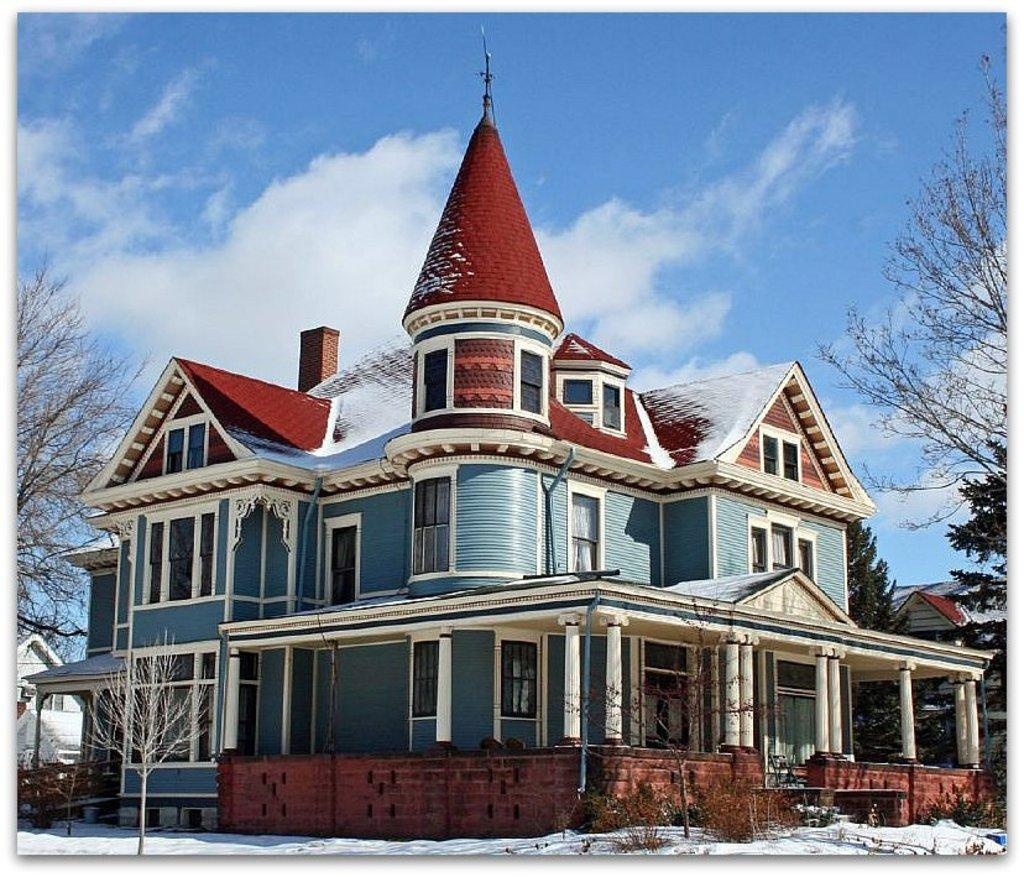What type of structure is in the image? There is a building in the image. What colors are used on the building? The building has blue, white, and red colors. What can be seen on both sides of the image? Trees are present on both sides of the image. What is visible in the background of the image? The sky is blue in the background of the image, and there are clouds visible in the sky. What color is the eye of the person standing in front of the building? There is no person standing in front of the building in the image, so it is not possible to determine the color of their eye. 